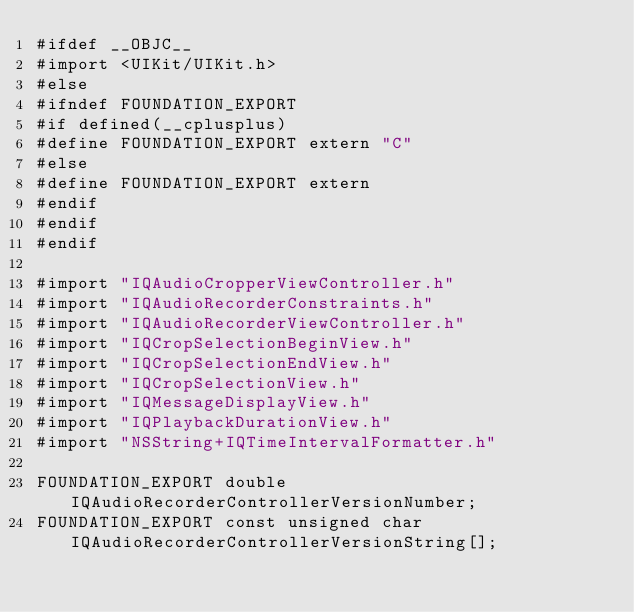Convert code to text. <code><loc_0><loc_0><loc_500><loc_500><_C_>#ifdef __OBJC__
#import <UIKit/UIKit.h>
#else
#ifndef FOUNDATION_EXPORT
#if defined(__cplusplus)
#define FOUNDATION_EXPORT extern "C"
#else
#define FOUNDATION_EXPORT extern
#endif
#endif
#endif

#import "IQAudioCropperViewController.h"
#import "IQAudioRecorderConstraints.h"
#import "IQAudioRecorderViewController.h"
#import "IQCropSelectionBeginView.h"
#import "IQCropSelectionEndView.h"
#import "IQCropSelectionView.h"
#import "IQMessageDisplayView.h"
#import "IQPlaybackDurationView.h"
#import "NSString+IQTimeIntervalFormatter.h"

FOUNDATION_EXPORT double IQAudioRecorderControllerVersionNumber;
FOUNDATION_EXPORT const unsigned char IQAudioRecorderControllerVersionString[];

</code> 